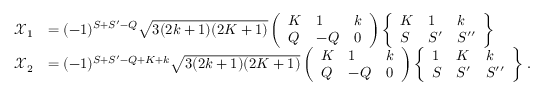<formula> <loc_0><loc_0><loc_500><loc_500>\begin{array} { r l } { \mathcal { X } _ { 1 } } & { = ( - 1 ) ^ { S + S ^ { \prime } - Q } \sqrt { 3 ( 2 k + 1 ) ( 2 K + 1 ) } \left ( \begin{array} { l l l } { K } & { 1 } & { k } \\ { Q } & { - Q } & { 0 } \end{array} \right ) \left \{ \begin{array} { l l l } { K } & { 1 } & { k } \\ { S } & { S ^ { \prime } } & { S ^ { \prime \prime } } \end{array} \right \} } \\ { \mathcal { X } _ { 2 } } & { = ( - 1 ) ^ { S + S ^ { \prime } - Q + K + k } \sqrt { 3 ( 2 k + 1 ) ( 2 K + 1 ) } \left ( \begin{array} { l l l } { K } & { 1 } & { k } \\ { Q } & { - Q } & { 0 } \end{array} \right ) \left \{ \begin{array} { l l l } { 1 } & { K } & { k } \\ { S } & { S ^ { \prime } } & { S ^ { \prime \prime } } \end{array} \right \} \, . } \end{array}</formula> 